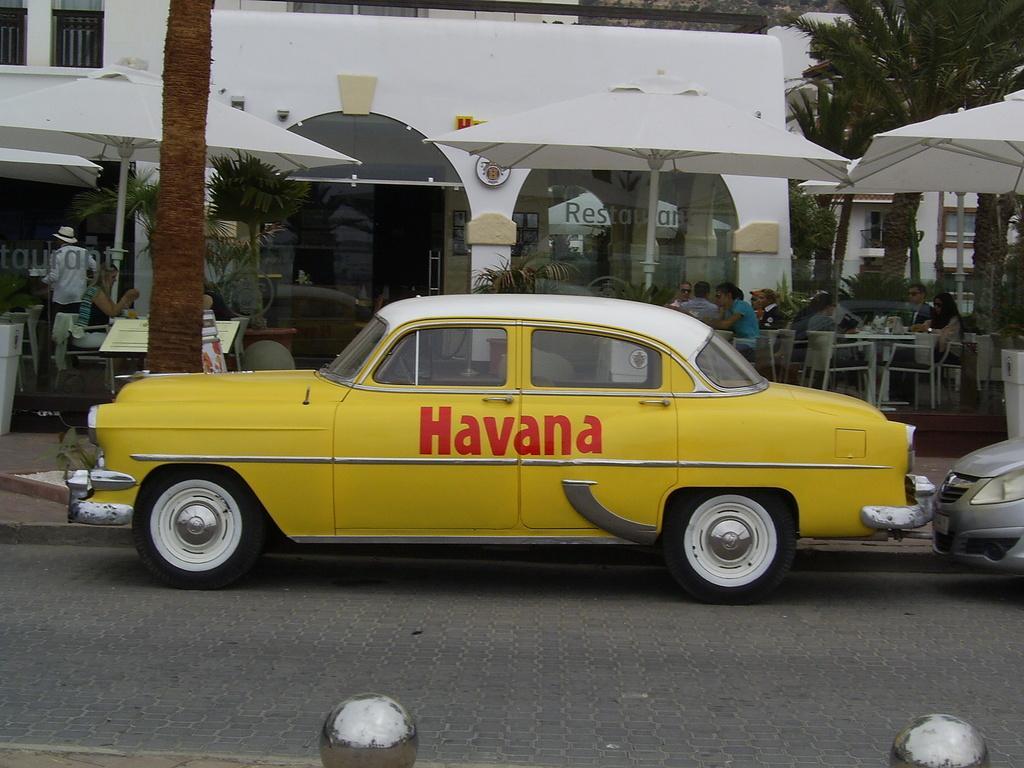Could you give a brief overview of what you see in this image? In this picture I can see 2 silver color things and I can see the path on which there are 2 cars. In the background I can see the plants, trees, number of tables and number of people who are sitting on chairs and I can see a building. I can also see few umbrellas. 